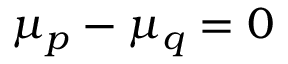<formula> <loc_0><loc_0><loc_500><loc_500>\mu _ { p } - \mu _ { q } = 0</formula> 